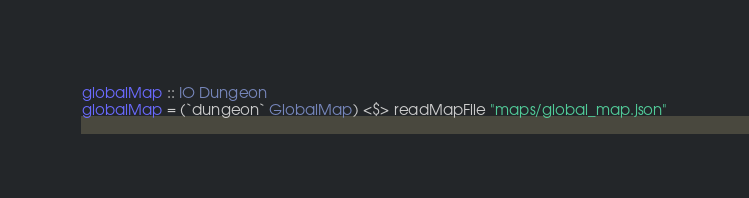Convert code to text. <code><loc_0><loc_0><loc_500><loc_500><_Haskell_>
globalMap :: IO Dungeon
globalMap = (`dungeon` GlobalMap) <$> readMapFile "maps/global_map.json"
</code> 